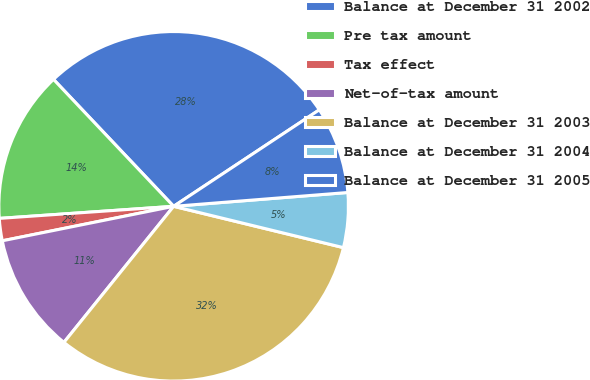<chart> <loc_0><loc_0><loc_500><loc_500><pie_chart><fcel>Balance at December 31 2002<fcel>Pre tax amount<fcel>Tax effect<fcel>Net-of-tax amount<fcel>Balance at December 31 2003<fcel>Balance at December 31 2004<fcel>Balance at December 31 2005<nl><fcel>27.75%<fcel>14.04%<fcel>2.06%<fcel>11.04%<fcel>32.0%<fcel>5.06%<fcel>8.05%<nl></chart> 